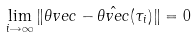<formula> <loc_0><loc_0><loc_500><loc_500>\lim _ { i \rightarrow \infty } \| \theta v e c - \hat { \theta v e c } ( \tau _ { i } ) \| = 0</formula> 